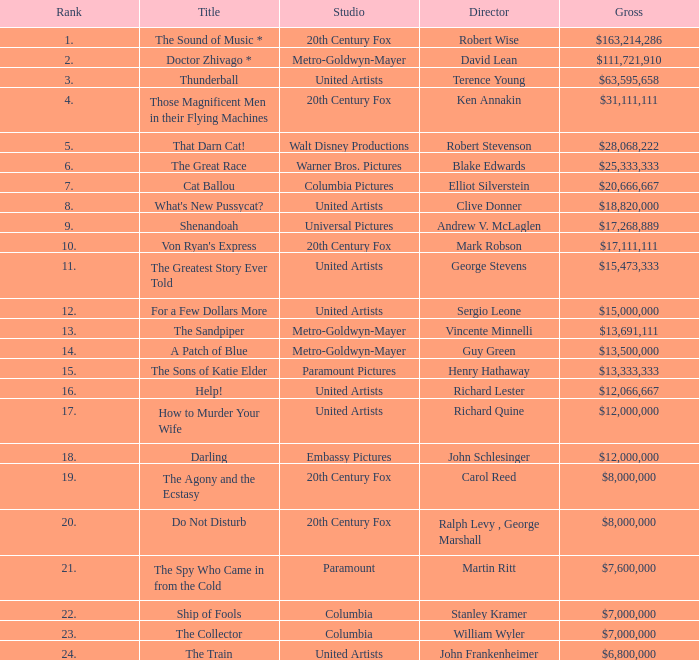What is Title, when Studio is "Embassy Pictures"? Darling. 